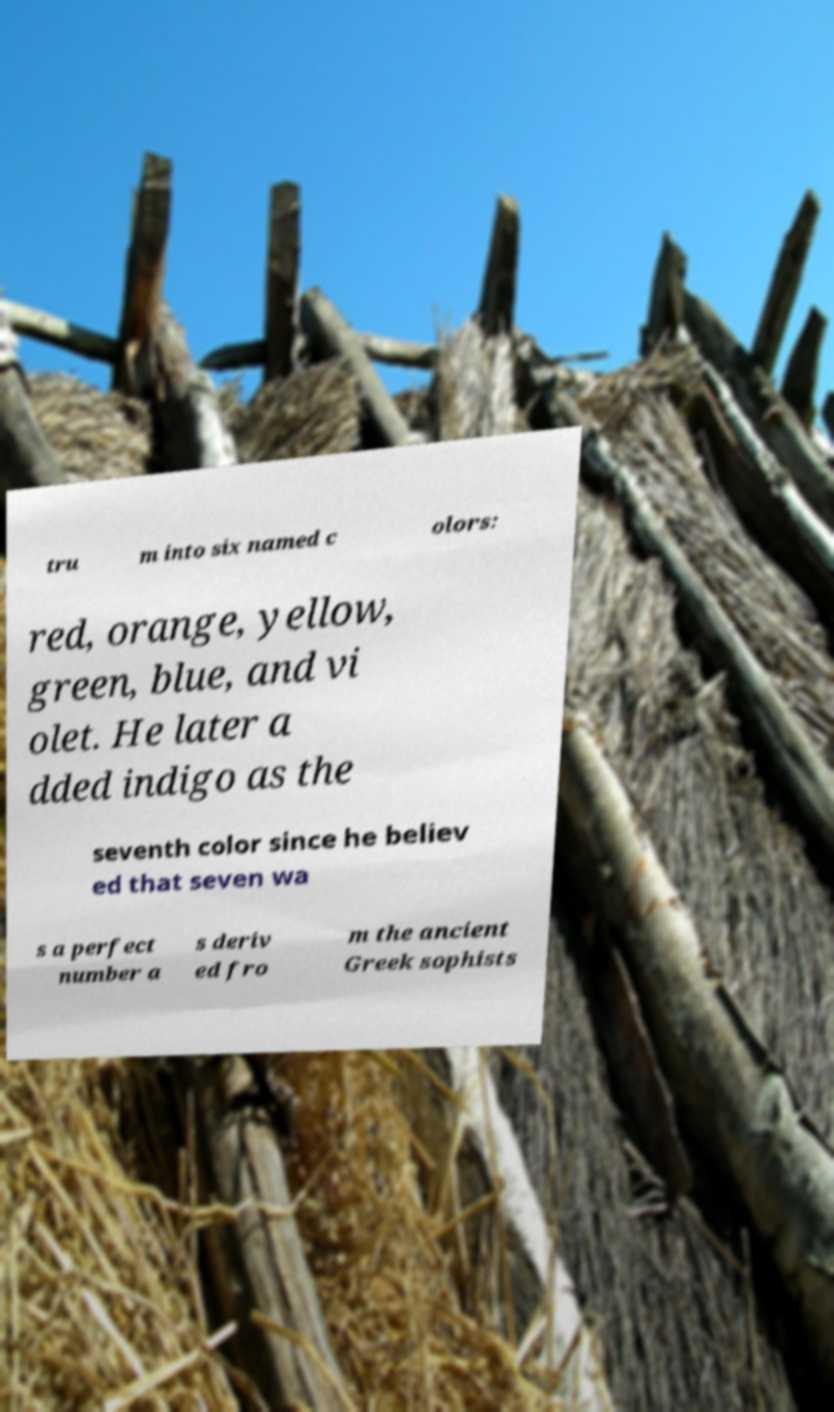Could you extract and type out the text from this image? tru m into six named c olors: red, orange, yellow, green, blue, and vi olet. He later a dded indigo as the seventh color since he believ ed that seven wa s a perfect number a s deriv ed fro m the ancient Greek sophists 